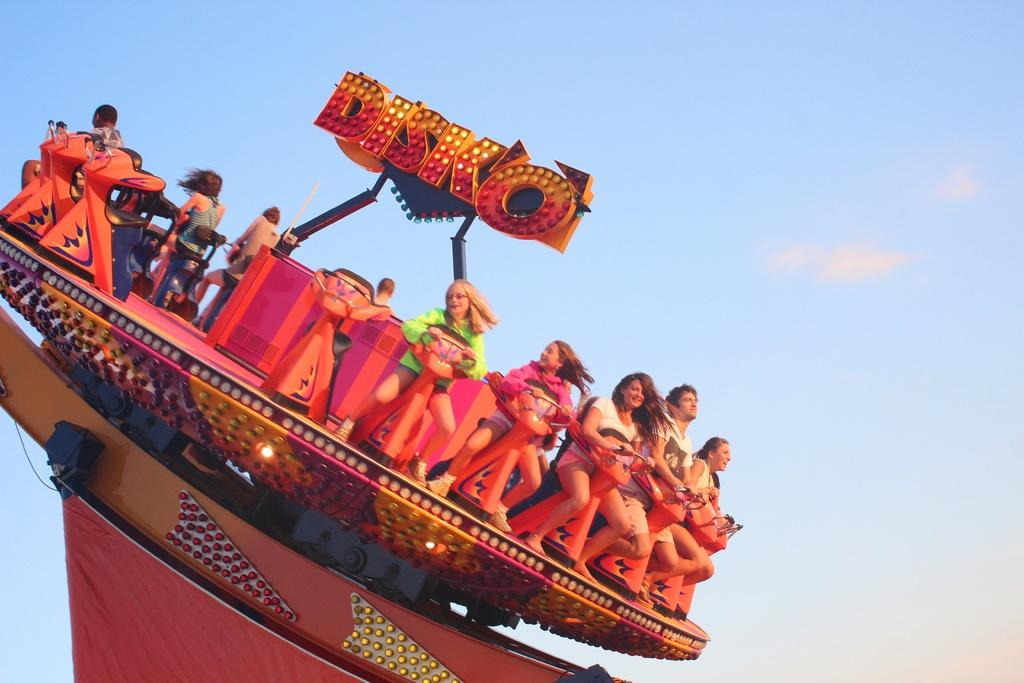What are the people in the image doing? The people in the image are sitting on a ride. What else can be seen in the image besides the people on the ride? There is a board in the image. What can be seen in the background of the image? The sky is visible in the background of the image. What type of hook is used to hang winter clothes on the board in the image? There is no hook or winter clothes present in the image; it only features people sitting on a ride and a board. 